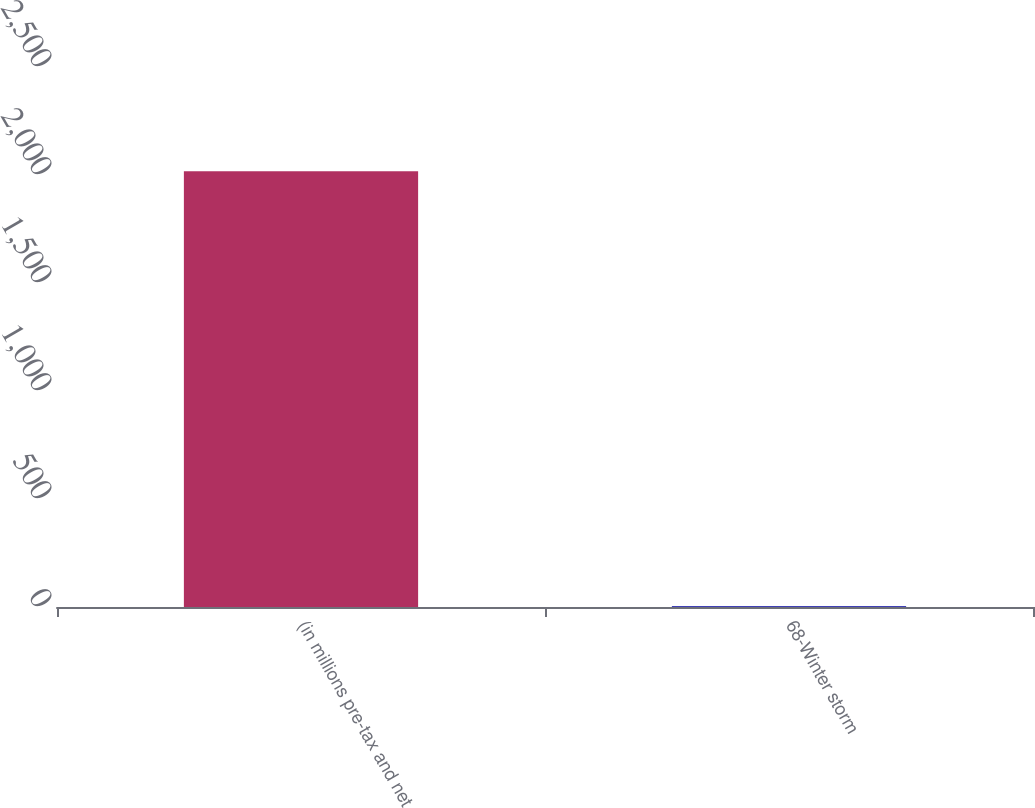Convert chart. <chart><loc_0><loc_0><loc_500><loc_500><bar_chart><fcel>(in millions pre-tax and net<fcel>68-Winter storm<nl><fcel>2017<fcel>3<nl></chart> 